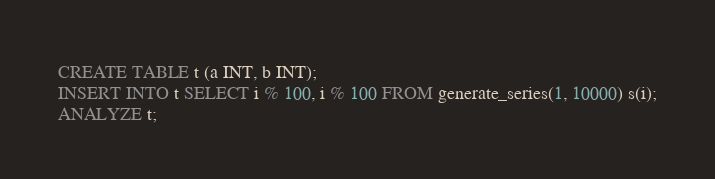Convert code to text. <code><loc_0><loc_0><loc_500><loc_500><_SQL_>CREATE TABLE t (a INT, b INT);
INSERT INTO t SELECT i % 100, i % 100 FROM generate_series(1, 10000) s(i);
ANALYZE t;
</code> 